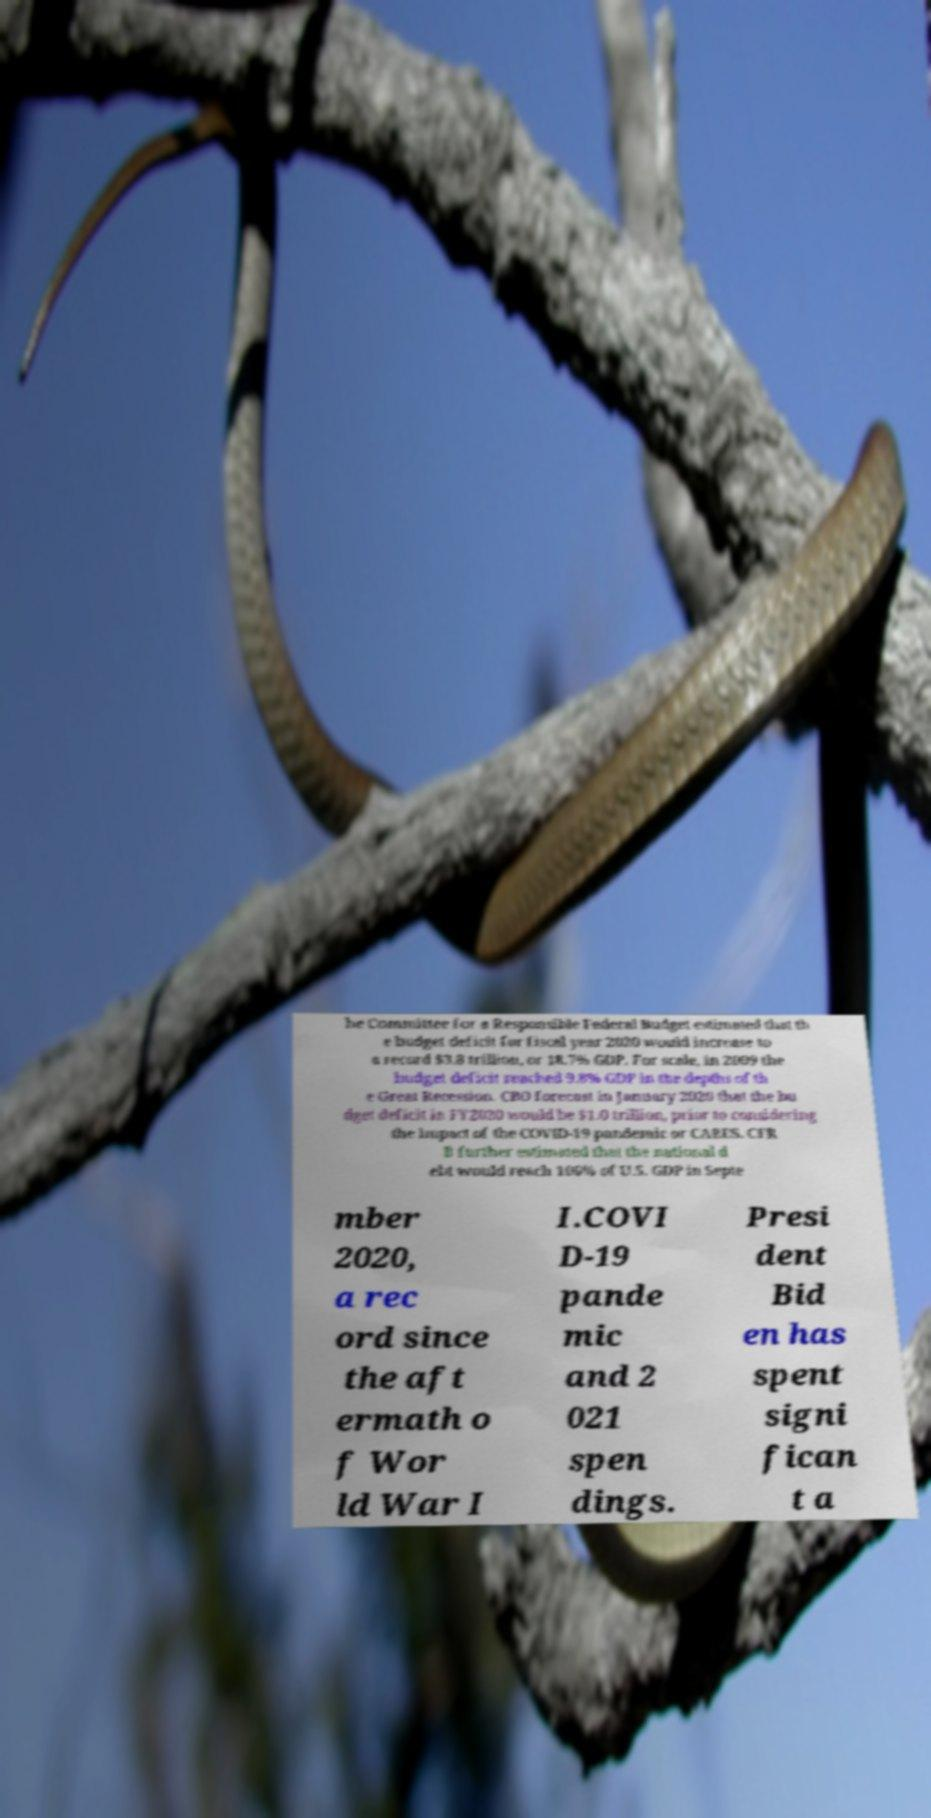For documentation purposes, I need the text within this image transcribed. Could you provide that? he Committee for a Responsible Federal Budget estimated that th e budget deficit for fiscal year 2020 would increase to a record $3.8 trillion, or 18.7% GDP. For scale, in 2009 the budget deficit reached 9.8% GDP in the depths of th e Great Recession. CBO forecast in January 2020 that the bu dget deficit in FY2020 would be $1.0 trillion, prior to considering the impact of the COVID-19 pandemic or CARES. CFR B further estimated that the national d ebt would reach 106% of U.S. GDP in Septe mber 2020, a rec ord since the aft ermath o f Wor ld War I I.COVI D-19 pande mic and 2 021 spen dings. Presi dent Bid en has spent signi fican t a 